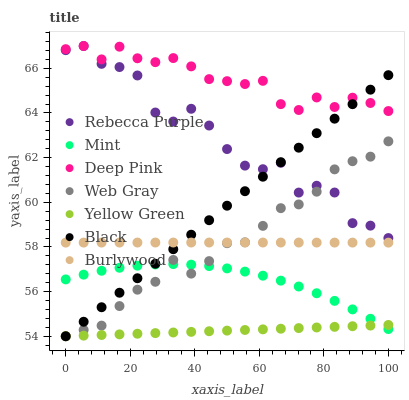Does Yellow Green have the minimum area under the curve?
Answer yes or no. Yes. Does Deep Pink have the maximum area under the curve?
Answer yes or no. Yes. Does Burlywood have the minimum area under the curve?
Answer yes or no. No. Does Burlywood have the maximum area under the curve?
Answer yes or no. No. Is Yellow Green the smoothest?
Answer yes or no. Yes. Is Rebecca Purple the roughest?
Answer yes or no. Yes. Is Burlywood the smoothest?
Answer yes or no. No. Is Burlywood the roughest?
Answer yes or no. No. Does Web Gray have the lowest value?
Answer yes or no. Yes. Does Burlywood have the lowest value?
Answer yes or no. No. Does Rebecca Purple have the highest value?
Answer yes or no. Yes. Does Burlywood have the highest value?
Answer yes or no. No. Is Mint less than Rebecca Purple?
Answer yes or no. Yes. Is Rebecca Purple greater than Burlywood?
Answer yes or no. Yes. Does Yellow Green intersect Black?
Answer yes or no. Yes. Is Yellow Green less than Black?
Answer yes or no. No. Is Yellow Green greater than Black?
Answer yes or no. No. Does Mint intersect Rebecca Purple?
Answer yes or no. No. 